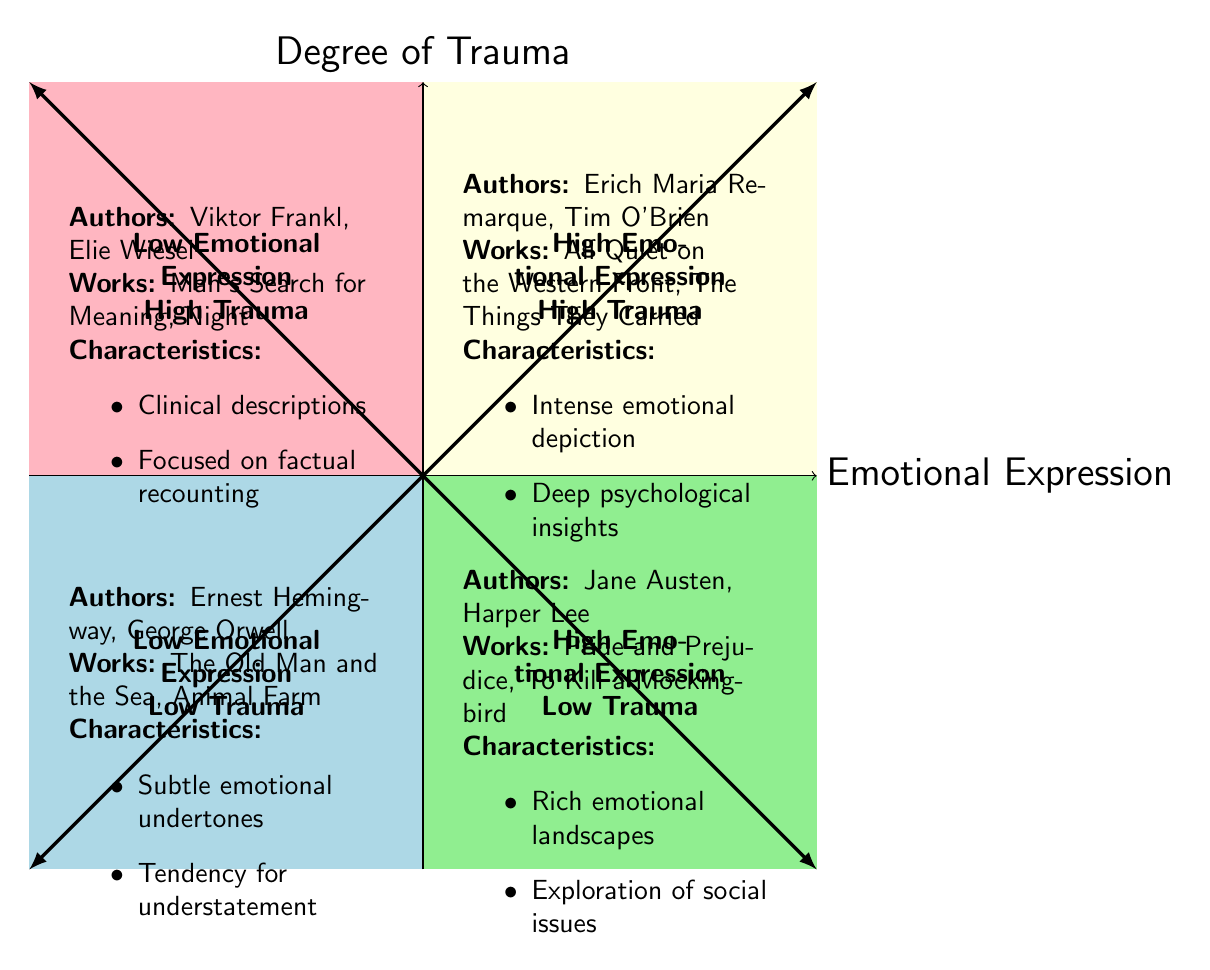What authors are in the "High Emotional Expression, High Trauma" quadrant? The quadrant labeled "High Emotional Expression, High Trauma" lists the authors Erich Maria Remarque and Tim O'Brien. By looking at the quadrant in the upper right of the chart, we can identify the authors mentioned in this specific area.
Answer: Erich Maria Remarque, Tim O'Brien How many authors are listed in the "Low Emotional Expression, Low Trauma" quadrant? The "Low Emotional Expression, Low Trauma" quadrant contains two authors: Ernest Hemingway and George Orwell. Counting the names listed within this quadrant gives us the total.
Answer: 2 What is a characteristic of the authors in the "Low Emotional Expression, High Trauma" quadrant? The characteristic of authors in the "Low Emotional Expression, High Trauma" quadrant, specifically Viktor Frankl and Elie Wiesel, is that they provide clinical descriptions and focus on factual recounting. Analyzing the points associated with this quadrant reveals these traits.
Answer: Clinical descriptions Which quadrant contains Jane Austen? Jane Austen is mentioned in the "High Emotional Expression, Low Trauma" quadrant. By noting the quadrants and the authors associated with each, we determine that she belongs to the quadrant dealing with high emotional expression and low trauma.
Answer: High Emotional Expression, Low Trauma Which quadrant has intense emotional depiction as a defining characteristic? The "High Emotional Expression, High Trauma" quadrant has intense emotional depiction as a defining characteristic. By checking the characteristics associated with the relevant quadrant, we can conclude this point.
Answer: High Emotional Expression, High Trauma What works are associated with authors in the "Low Emotional Expression, Low Trauma" quadrant? The works associated with the authors in the "Low Emotional Expression, Low Trauma" quadrant are "The Old Man and the Sea" and "Animal Farm." By examining the example works listed within this quadrant, we can identify them.
Answer: The Old Man and the Sea, Animal Farm Which quadrant features works focused on social issues? The "High Emotional Expression, Low Trauma" quadrant features works that explore social issues. By discerning the focus of storytelling within this quadrant, we find this characteristic is accurately described here.
Answer: High Emotional Expression, Low Trauma 